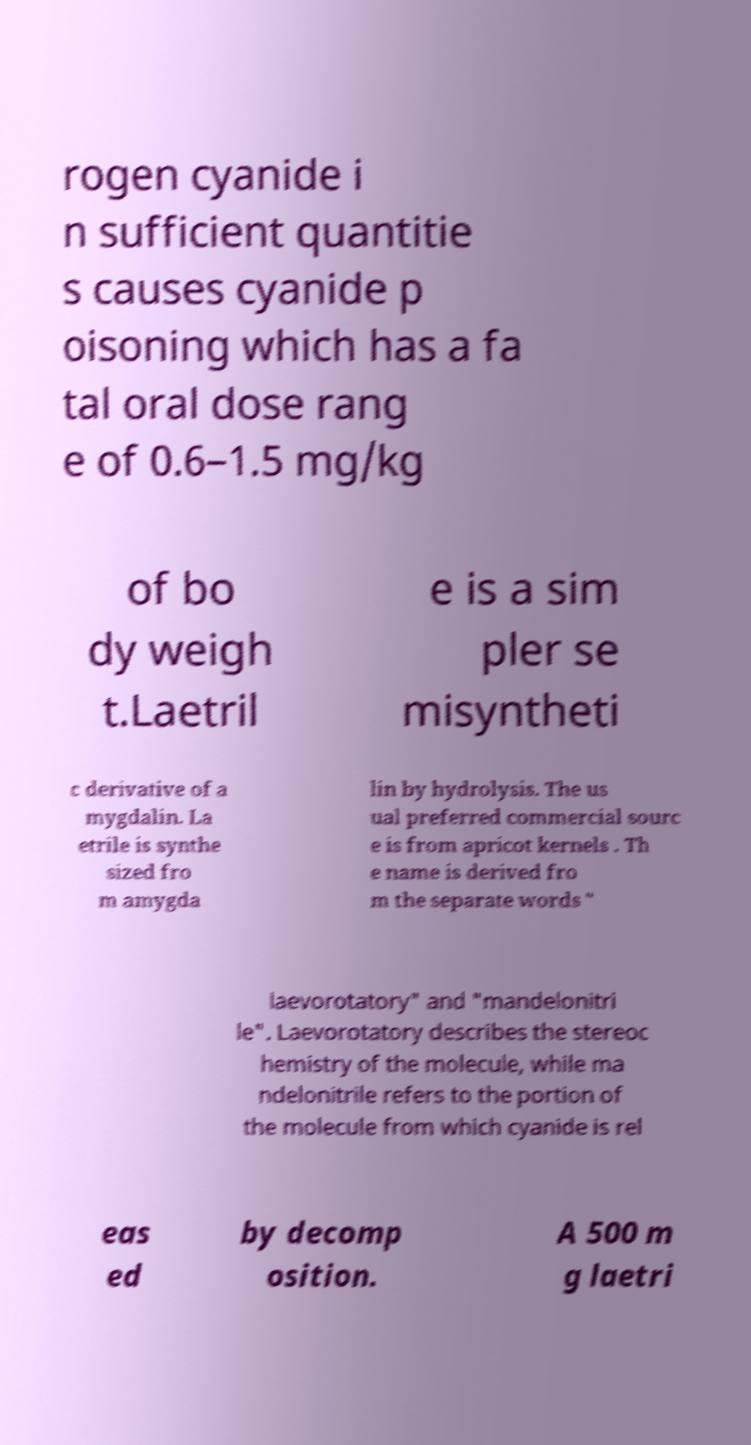Could you assist in decoding the text presented in this image and type it out clearly? rogen cyanide i n sufficient quantitie s causes cyanide p oisoning which has a fa tal oral dose rang e of 0.6–1.5 mg/kg of bo dy weigh t.Laetril e is a sim pler se misyntheti c derivative of a mygdalin. La etrile is synthe sized fro m amygda lin by hydrolysis. The us ual preferred commercial sourc e is from apricot kernels . Th e name is derived fro m the separate words " laevorotatory" and "mandelonitri le". Laevorotatory describes the stereoc hemistry of the molecule, while ma ndelonitrile refers to the portion of the molecule from which cyanide is rel eas ed by decomp osition. A 500 m g laetri 